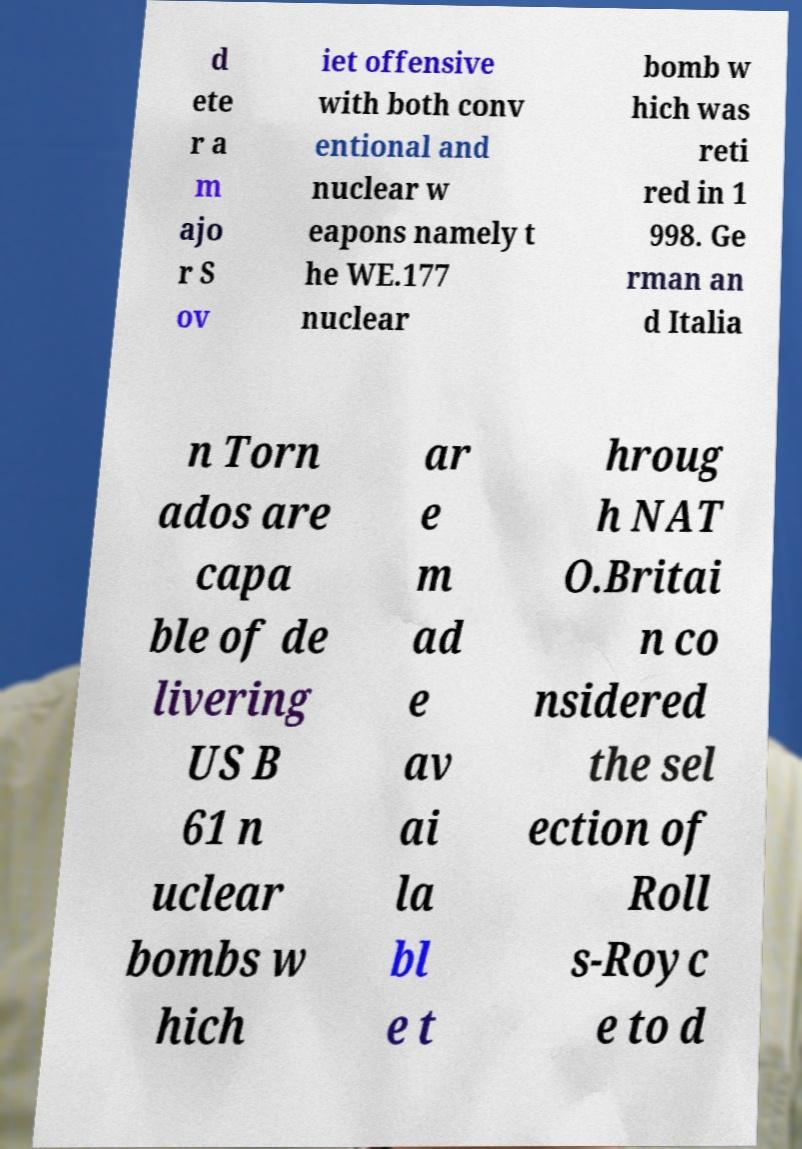Can you read and provide the text displayed in the image?This photo seems to have some interesting text. Can you extract and type it out for me? d ete r a m ajo r S ov iet offensive with both conv entional and nuclear w eapons namely t he WE.177 nuclear bomb w hich was reti red in 1 998. Ge rman an d Italia n Torn ados are capa ble of de livering US B 61 n uclear bombs w hich ar e m ad e av ai la bl e t hroug h NAT O.Britai n co nsidered the sel ection of Roll s-Royc e to d 